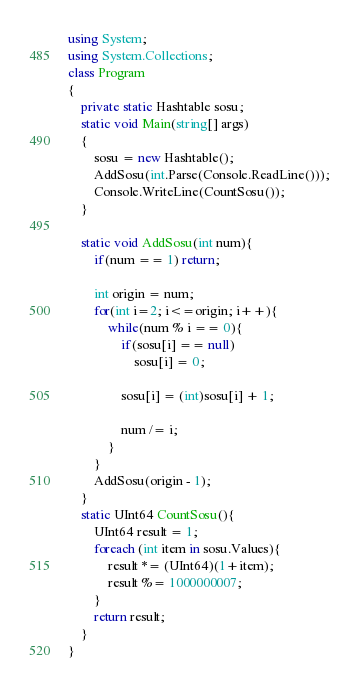<code> <loc_0><loc_0><loc_500><loc_500><_C#_>using System;
using System.Collections;
class Program
{
	private static Hashtable sosu;
	static void Main(string[] args)
	{
		sosu = new Hashtable();
		AddSosu(int.Parse(Console.ReadLine()));
		Console.WriteLine(CountSosu());
	}

	static void AddSosu(int num){
		if(num == 1) return;

		int origin = num;
		for(int i=2; i<=origin; i++){
			while(num % i == 0){
				if(sosu[i] == null)
					sosu[i] = 0;
				
				sosu[i] = (int)sosu[i] + 1;

				num /= i;
			}
		}
		AddSosu(origin - 1);
	}
	static UInt64 CountSosu(){
		UInt64 result = 1;
		foreach (int item in sosu.Values){
			result *= (UInt64)(1+item);
			result %= 1000000007;
		}
		return result;
	}
}</code> 